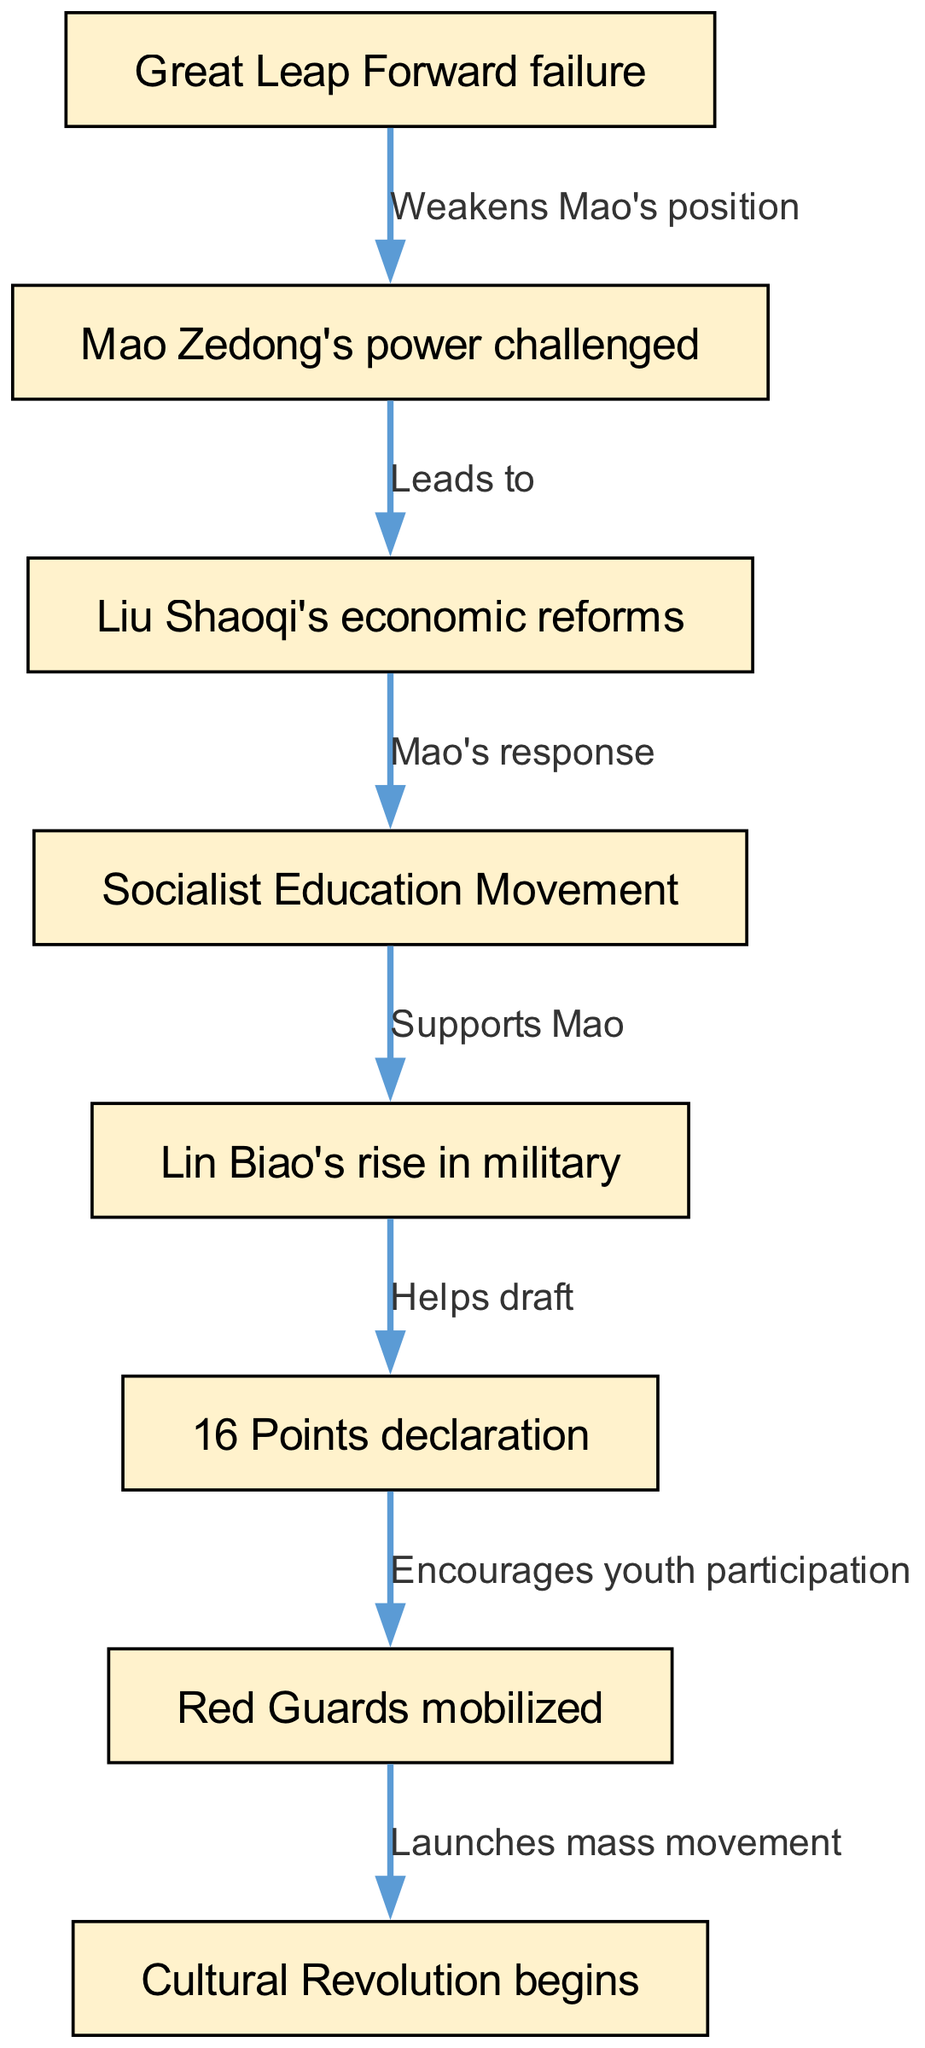What weakened Mao's position? The diagram indicates that the "Great Leap Forward failure" led to "Mao Zedong's power challenged," showing that this failure was a significant factor in weakening Mao's authority.
Answer: Great Leap Forward failure What event follows Liu Shaoqi's economic reforms? According to the diagram, Liu Shaoqi's economic reforms directly lead to the "Socialist Education Movement," indicating that this movement was a response to those reforms.
Answer: Socialist Education Movement Which movement encouraged youth participation? The diagram shows that the "16 Points declaration" leads to the "Red Guards mobilized," stating that the declaration played a crucial role in inspiring and mobilizing the youth.
Answer: Red Guards mobilized How many nodes are in this diagram? The diagram lists a total of 8 distinct nodes that represent key events and figures leading to the Cultural Revolution, counting each uniquely.
Answer: 8 What supports Mao during the Socialist Education Movement? The edge from the "Socialist Education Movement" to "Lin Biao's rise in military" indicates that this movement was instrumental in supporting Mao, particularly through Lin Biao's increasing military prominence.
Answer: Lin Biao's rise in military What initiates the Cultural Revolution? The final step shown in the diagram indicates that the "Red Guards mobilized" directly leads to the "Cultural Revolution begins," illustrating that the mobilization of the Red Guards marked the start of this significant movement.
Answer: Red Guards mobilized Which event helps draft the 16 Points declaration? The diagram specifies that "Lin Biao's rise in military" helps draft the "16 Points declaration," indicating Lin Biao's critical role in formulating this key document.
Answer: Lin Biao's rise in military What was Mao's response to economic reforms? The directed edge from "Liu Shaoqi's economic reforms" to "Socialist Education Movement" indicates that Mao's response to these reforms was to initiate the Socialist Education Movement.
Answer: Socialist Education Movement What type of graph is used to represent these events? The representation in the diagram is a directed graph, which showcases the flow and relationships between various events and decisions.
Answer: Directed graph 